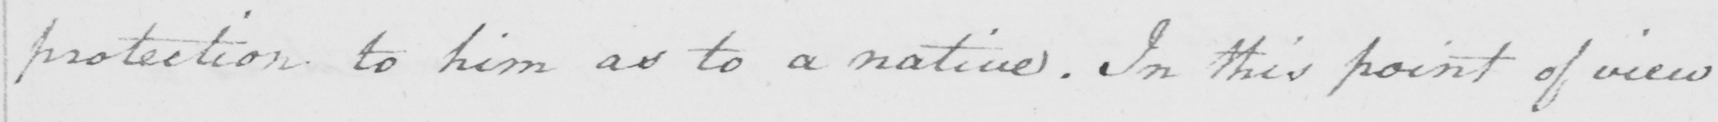What is written in this line of handwriting? protection to him as to a native . In this point of view 